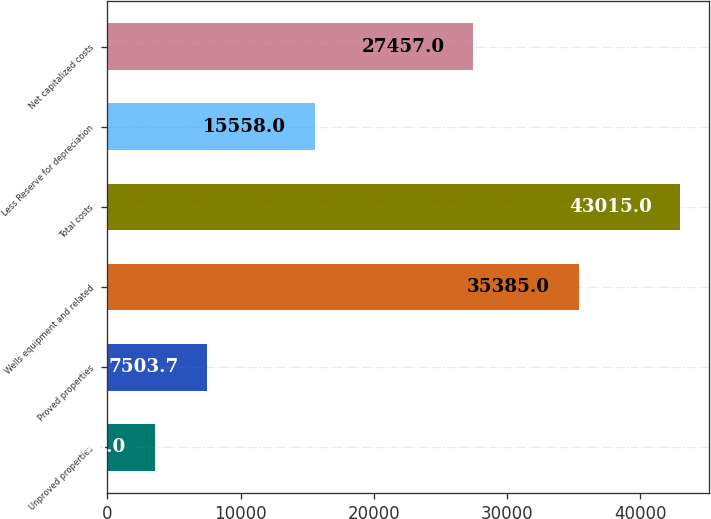<chart> <loc_0><loc_0><loc_500><loc_500><bar_chart><fcel>Unproved properties<fcel>Proved properties<fcel>Wells equipment and related<fcel>Total costs<fcel>Less Reserve for depreciation<fcel>Net capitalized costs<nl><fcel>3558<fcel>7503.7<fcel>35385<fcel>43015<fcel>15558<fcel>27457<nl></chart> 